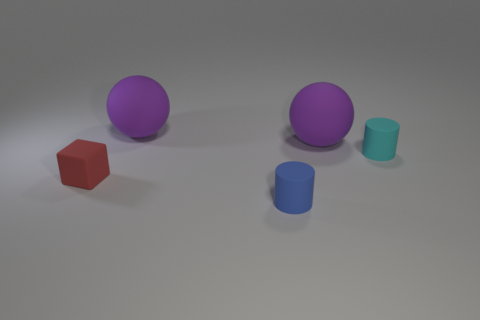Add 1 matte balls. How many objects exist? 6 Subtract all cubes. How many objects are left? 4 Subtract 0 cyan spheres. How many objects are left? 5 Subtract all blue matte things. Subtract all tiny cyan things. How many objects are left? 3 Add 4 tiny cyan objects. How many tiny cyan objects are left? 5 Add 5 large blue metal things. How many large blue metal things exist? 5 